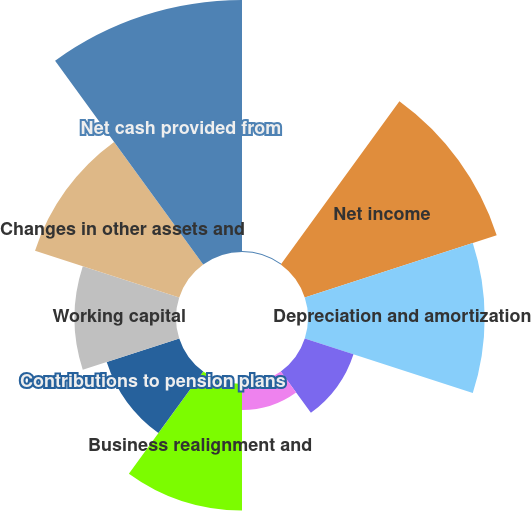<chart> <loc_0><loc_0><loc_500><loc_500><pie_chart><fcel>For the years ended December<fcel>Net income<fcel>Depreciation and amortization<fcel>Stock-based compensation and<fcel>Deferred income taxes<fcel>Business realignment and<fcel>Contributions to pension plans<fcel>Working capital<fcel>Changes in other assets and<fcel>Net cash provided from<nl><fcel>0.08%<fcel>17.33%<fcel>15.17%<fcel>4.4%<fcel>2.24%<fcel>10.86%<fcel>6.55%<fcel>8.71%<fcel>13.02%<fcel>21.64%<nl></chart> 